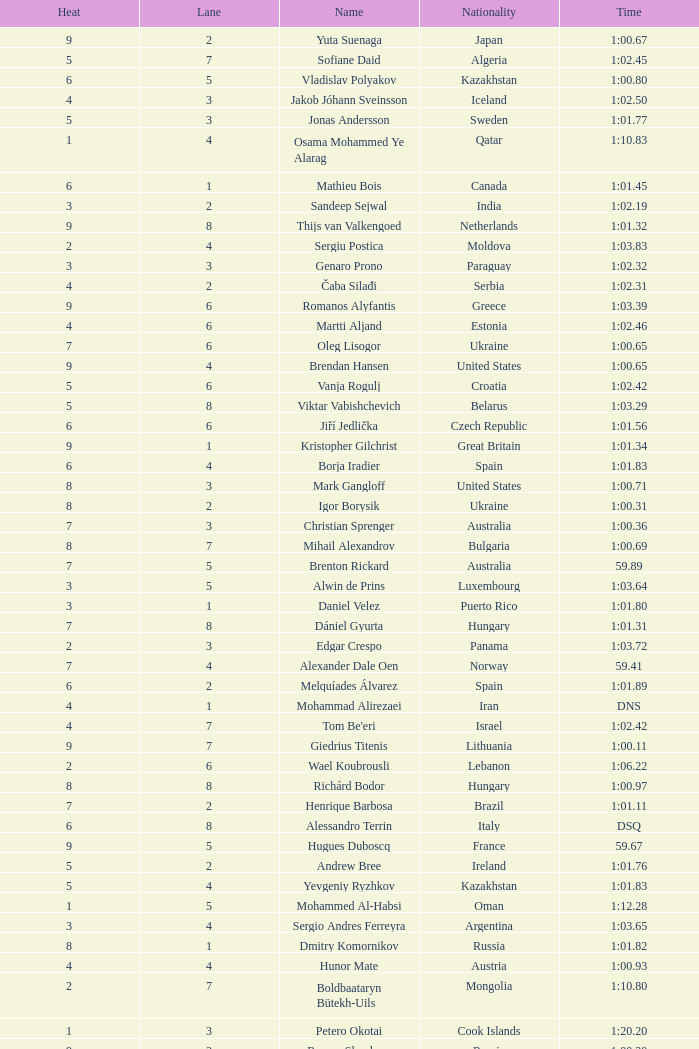What is the smallest lane number of Xue Ruipeng? 8.0. 